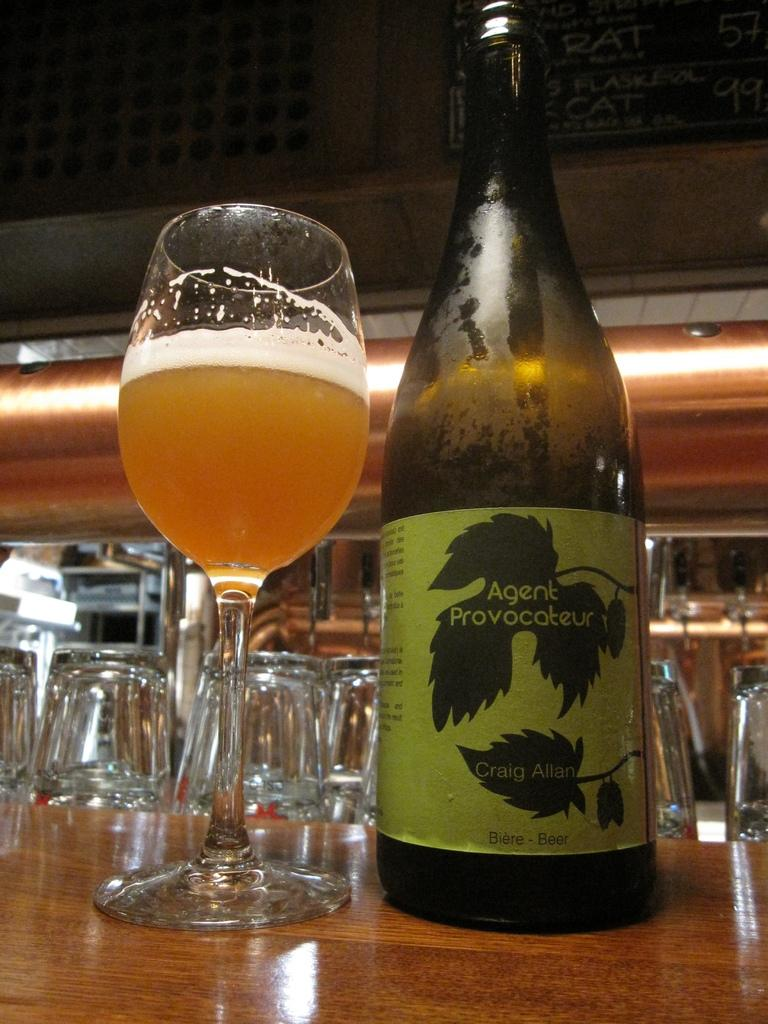<image>
Offer a succinct explanation of the picture presented. the name agent is on a large wine bottle 